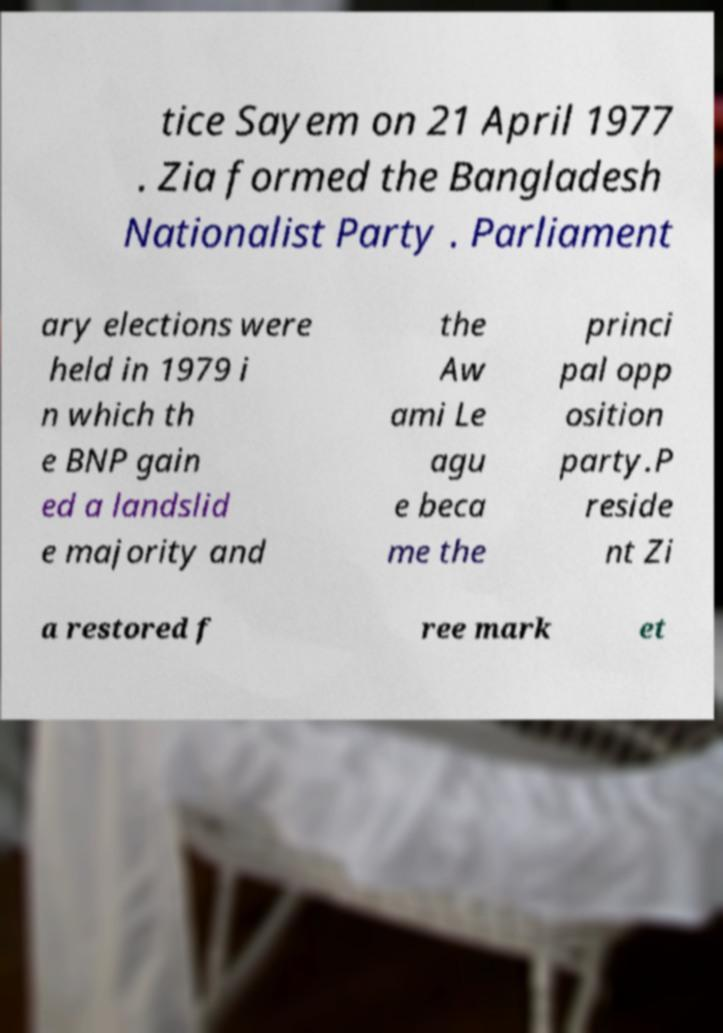Can you accurately transcribe the text from the provided image for me? tice Sayem on 21 April 1977 . Zia formed the Bangladesh Nationalist Party . Parliament ary elections were held in 1979 i n which th e BNP gain ed a landslid e majority and the Aw ami Le agu e beca me the princi pal opp osition party.P reside nt Zi a restored f ree mark et 